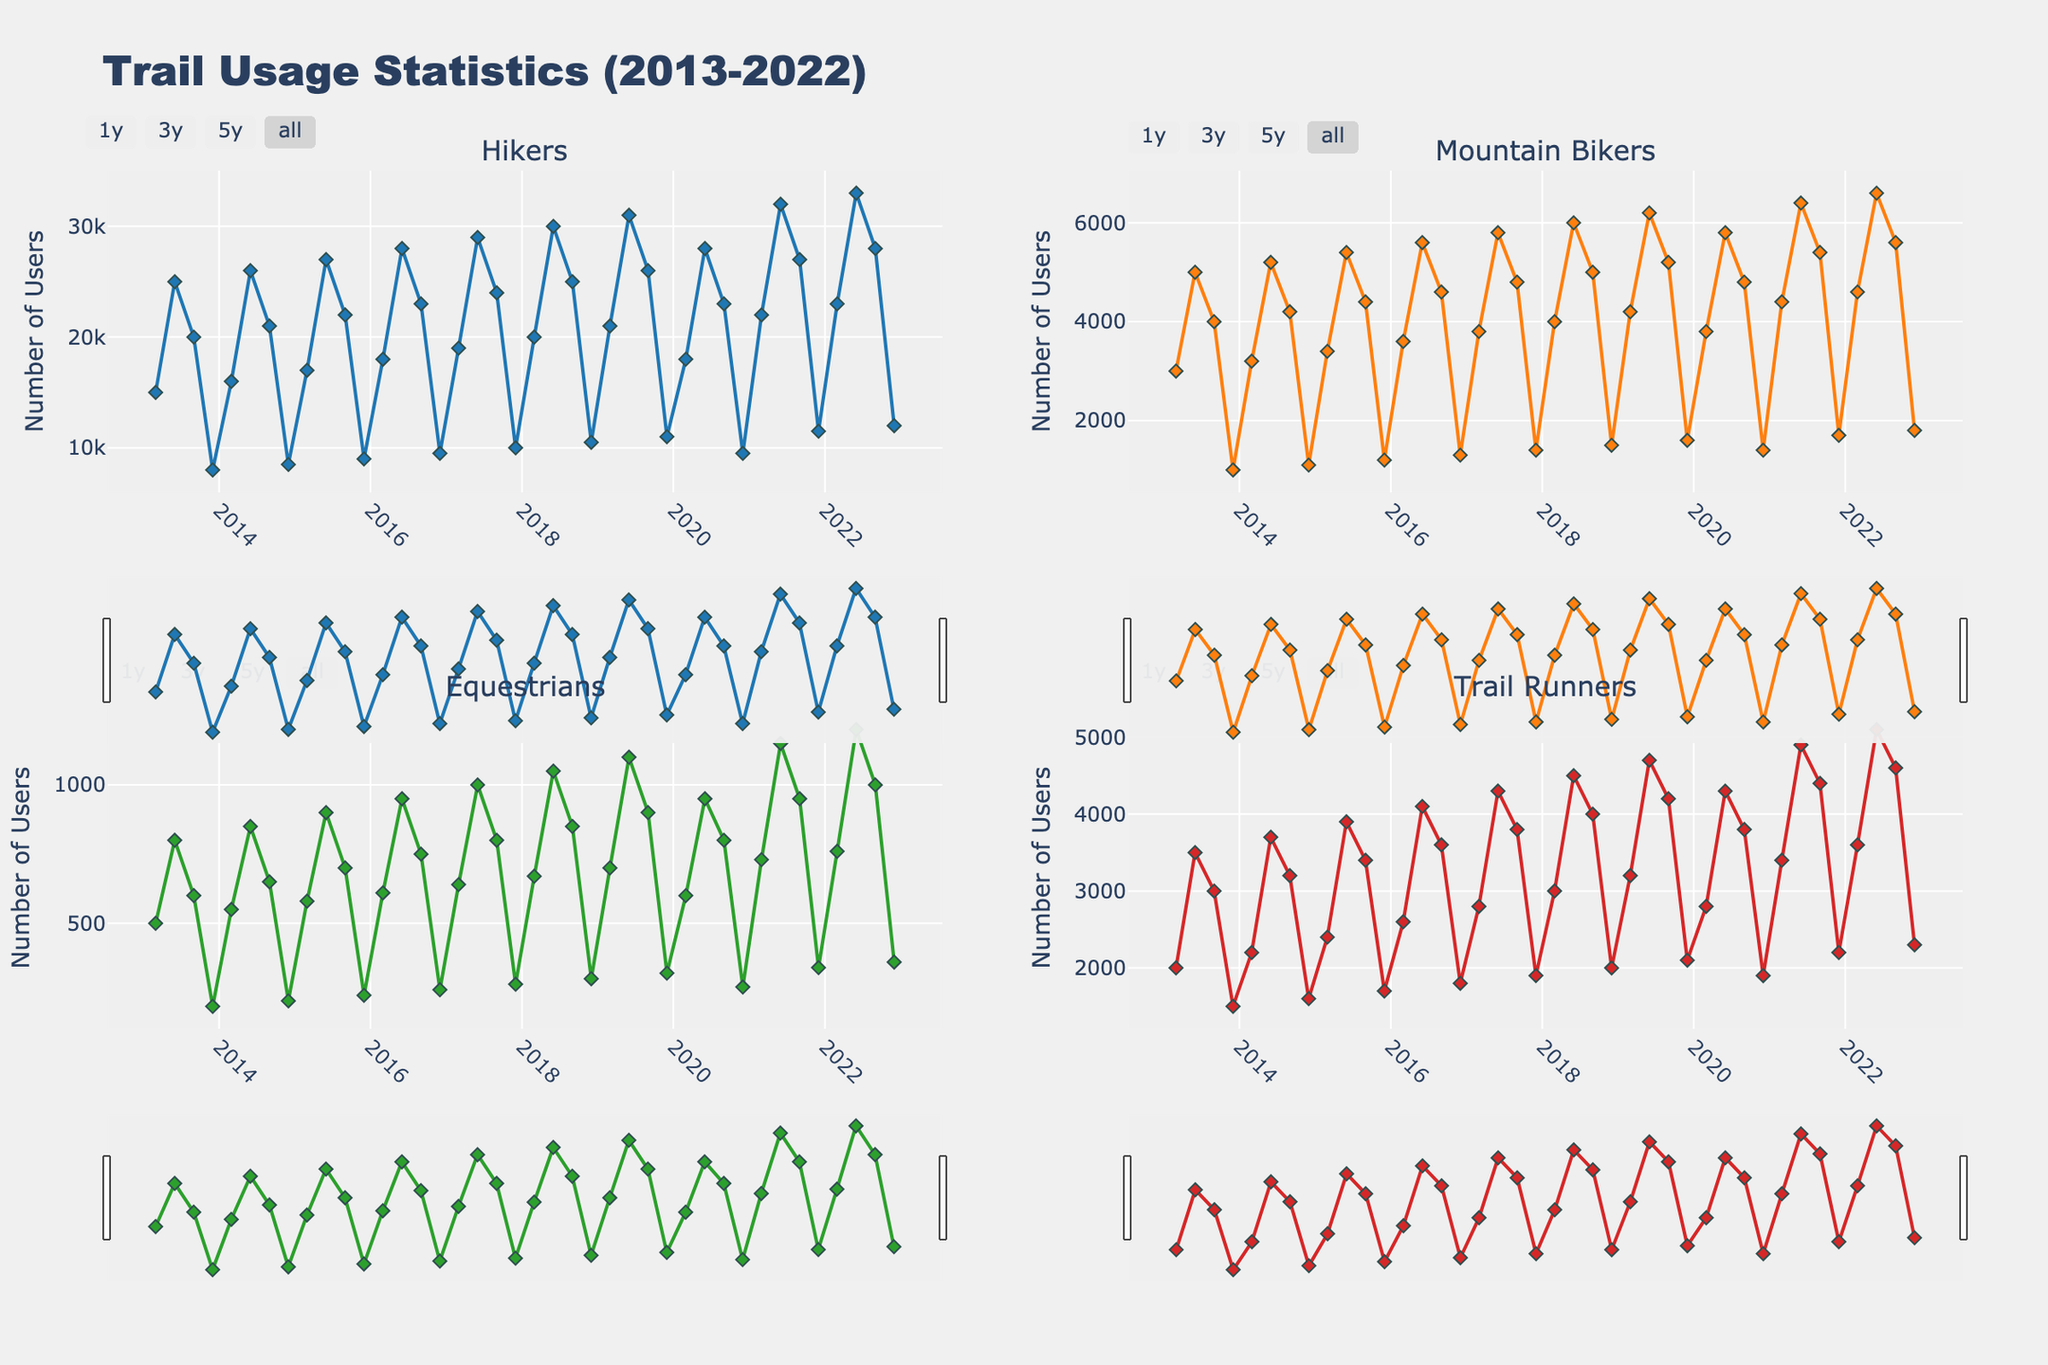What season has the highest trail usage by hikers in 2022? Look at the subplot for Hikers and find the highest point in 2022. The highest point occurs in Summer.
Answer: Summer Which user group experienced the most consistent increase over the last decade? Compare the slopes of the lines in each subplot for Hikers, Mountain Bikers, Equestrians, and Trail Runners over the years. The Mountain Bikers trend line shows a consistent increase across seasons.
Answer: Mountain Bikers How did the number of Trail Runners change from Winter 2013 to Winter 2022? Compare the values for Trail Runners in Winter 2013 and Winter 2022 by looking at their respective points in the Trail Runners subplot. The number increased from 1500 to 2300.
Answer: Increased by 800 Which season shows the highest trail usage across all user groups in 2019? Look at the peak values for Hikers, Mountain Bikers, Equestrians, and Trail Runners in 2019 across each season. All user groups peak in Summer 2019.
Answer: Summer Which user group had the smallest increase from Spring 2013 to Spring 2022? Calculate the difference in values between Spring 2013 and Spring 2022 for each user group by comparing the respective points in their subplots. The Equestrians had the smallest increase (from 500 to 760).
Answer: Equestrians What is the average number of Mountain Bikers across all seasons in 2019? Add the number of Mountain Bikers for Spring, Summer, Fall, and Winter in 2019, then divide by 4. (4200 + 6200 + 5200 + 1600) / 4 = 4300.
Answer: 4300 Who used the trail more in Summer 2018, Hikers or Trail Runners? Compare the values for Hikers and Trail Runners in Summer 2018 by looking at the respective points in their subplots. Hikers have 30,000 and Trail Runners have 4500.
Answer: Hikers What is the net change in the number of Hikers from Fall 2013 to Fall 2022? Subtract the number of Hikers in Fall 2013 from the number of Hikers in Fall 2022. 28000 - 20000 = 8000
Answer: Increased by 8000 